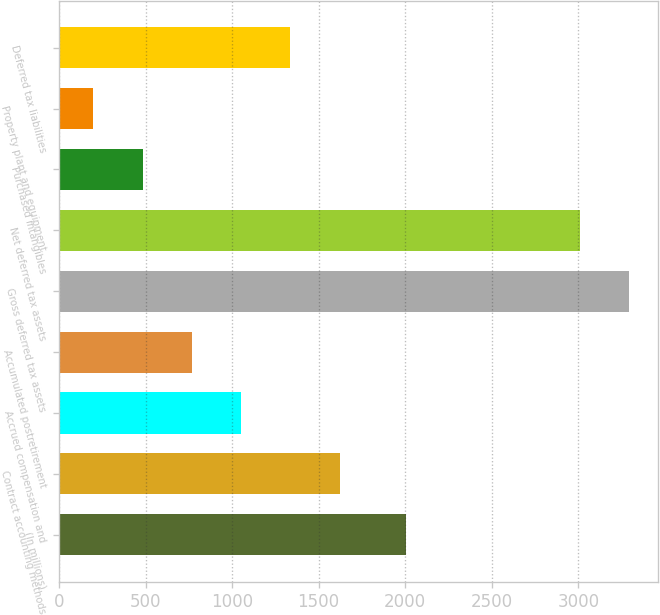Convert chart. <chart><loc_0><loc_0><loc_500><loc_500><bar_chart><fcel>(In millions)<fcel>Contract accounting methods<fcel>Accrued compensation and<fcel>Accumulated postretirement<fcel>Gross deferred tax assets<fcel>Net deferred tax assets<fcel>Purchased intangibles<fcel>Property plant and equipment<fcel>Deferred tax liabilities<nl><fcel>2006<fcel>1621.5<fcel>1052.5<fcel>768<fcel>3294.5<fcel>3010<fcel>483.5<fcel>199<fcel>1337<nl></chart> 